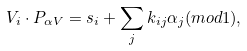<formula> <loc_0><loc_0><loc_500><loc_500>V _ { i } \cdot P _ { \alpha V } = s _ { i } + \sum _ { j } k _ { i j } \alpha _ { j } ( { m o d } 1 ) ,</formula> 